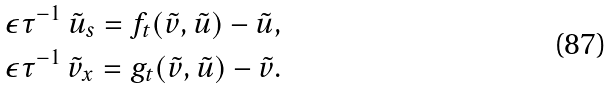<formula> <loc_0><loc_0><loc_500><loc_500>& \epsilon \tau ^ { - 1 } \ \tilde { u } _ { s } = f _ { t } ( \tilde { v } , \tilde { u } ) - \tilde { u } , \\ & \epsilon \tau ^ { - 1 } \ \tilde { v } _ { x } = g _ { t } ( \tilde { v } , \tilde { u } ) - \tilde { v } .</formula> 